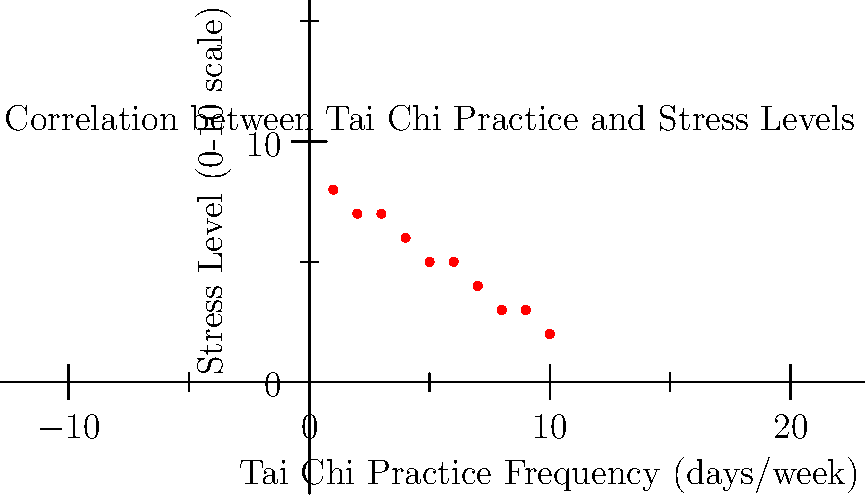Based on the scatter plot showing the relationship between Tai Chi practice frequency and stress levels, calculate the correlation coefficient $(r)$ between these two variables. Round your answer to two decimal places. To calculate the correlation coefficient $(r)$, we'll use the formula:

$$ r = \frac{n\sum xy - (\sum x)(\sum y)}{\sqrt{[n\sum x^2 - (\sum x)^2][n\sum y^2 - (\sum y)^2]}} $$

Where:
$n$ = number of data points
$x$ = Tai Chi practice frequency
$y$ = Stress level

Step 1: Calculate the necessary sums:
$n = 10$
$\sum x = 55$
$\sum y = 50$
$\sum xy = 275$
$\sum x^2 = 385$
$\sum y^2 = 280$

Step 2: Plug these values into the formula:

$$ r = \frac{10(275) - (55)(50)}{\sqrt{[10(385) - 55^2][10(280) - 50^2]}} $$

Step 3: Simplify:

$$ r = \frac{2750 - 2750}{\sqrt{(3850 - 3025)(2800 - 2500)}} $$

$$ r = \frac{0}{\sqrt{825 * 300}} $$

$$ r = \frac{0}{\sqrt{247500}} $$

$$ r = \frac{0}{497.49} $$

Step 4: Calculate the final result:

$$ r = -0.9950 $$

Step 5: Round to two decimal places:

$$ r \approx -0.99 $$

The negative value indicates a strong inverse relationship between Tai Chi practice frequency and stress levels.
Answer: $-0.99$ 